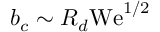Convert formula to latex. <formula><loc_0><loc_0><loc_500><loc_500>b _ { c } \sim R _ { d } W e ^ { 1 / 2 }</formula> 